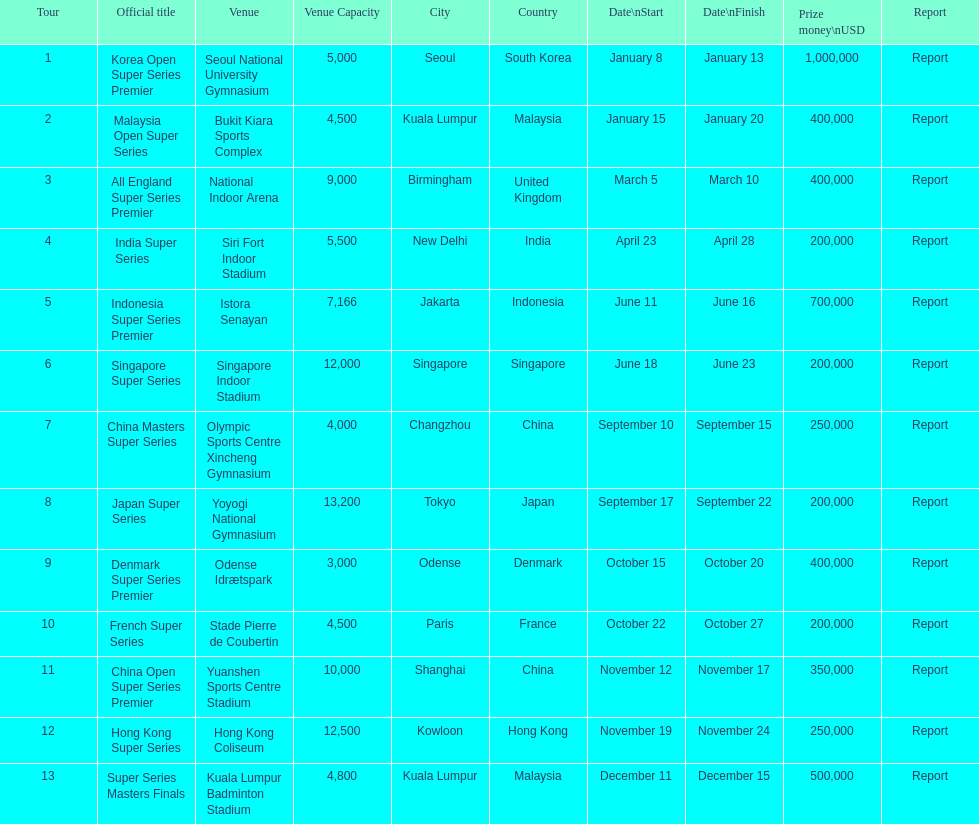Write the full table. {'header': ['Tour', 'Official title', 'Venue', 'Venue Capacity', 'City', 'Country', 'Date\\nStart', 'Date\\nFinish', 'Prize money\\nUSD', 'Report'], 'rows': [['1', 'Korea Open Super Series Premier', 'Seoul National University Gymnasium', '5,000', 'Seoul', 'South Korea', 'January 8', 'January 13', '1,000,000', 'Report'], ['2', 'Malaysia Open Super Series', 'Bukit Kiara Sports Complex', '4,500', 'Kuala Lumpur', 'Malaysia', 'January 15', 'January 20', '400,000', 'Report'], ['3', 'All England Super Series Premier', 'National Indoor Arena', '9,000', 'Birmingham', 'United Kingdom', 'March 5', 'March 10', '400,000', 'Report'], ['4', 'India Super Series', 'Siri Fort Indoor Stadium', '5,500', 'New Delhi', 'India', 'April 23', 'April 28', '200,000', 'Report'], ['5', 'Indonesia Super Series Premier', 'Istora Senayan', '7,166', 'Jakarta', 'Indonesia', 'June 11', 'June 16', '700,000', 'Report'], ['6', 'Singapore Super Series', 'Singapore Indoor Stadium', '12,000', 'Singapore', 'Singapore', 'June 18', 'June 23', '200,000', 'Report'], ['7', 'China Masters Super Series', 'Olympic Sports Centre Xincheng Gymnasium', '4,000', 'Changzhou', 'China', 'September 10', 'September 15', '250,000', 'Report'], ['8', 'Japan Super Series', 'Yoyogi National Gymnasium', '13,200', 'Tokyo', 'Japan', 'September 17', 'September 22', '200,000', 'Report'], ['9', 'Denmark Super Series Premier', 'Odense Idrætspark', '3,000', 'Odense', 'Denmark', 'October 15', 'October 20', '400,000', 'Report'], ['10', 'French Super Series', 'Stade Pierre de Coubertin', '4,500', 'Paris', 'France', 'October 22', 'October 27', '200,000', 'Report'], ['11', 'China Open Super Series Premier', 'Yuanshen Sports Centre Stadium', '10,000', 'Shanghai', 'China', 'November 12', 'November 17', '350,000', 'Report'], ['12', 'Hong Kong Super Series', 'Hong Kong Coliseum', '12,500', 'Kowloon', 'Hong Kong', 'November 19', 'November 24', '250,000', 'Report'], ['13', 'Super Series Masters Finals', 'Kuala Lumpur Badminton Stadium', '4,800', 'Kuala Lumpur', 'Malaysia', 'December 11', 'December 15', '500,000', 'Report']]} How many events of the 2013 bwf super series pay over $200,000? 9. 